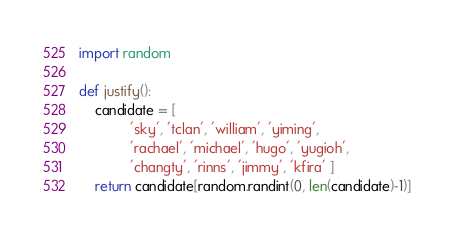Convert code to text. <code><loc_0><loc_0><loc_500><loc_500><_Python_>import random

def justify():
    candidate = [
             'sky', 'tclan', 'william', 'yiming',
             'rachael', 'michael', 'hugo', 'yugioh',
             'changty', 'rinns', 'jimmy', 'kfira' ]
    return candidate[random.randint(0, len(candidate)-1)]
</code> 